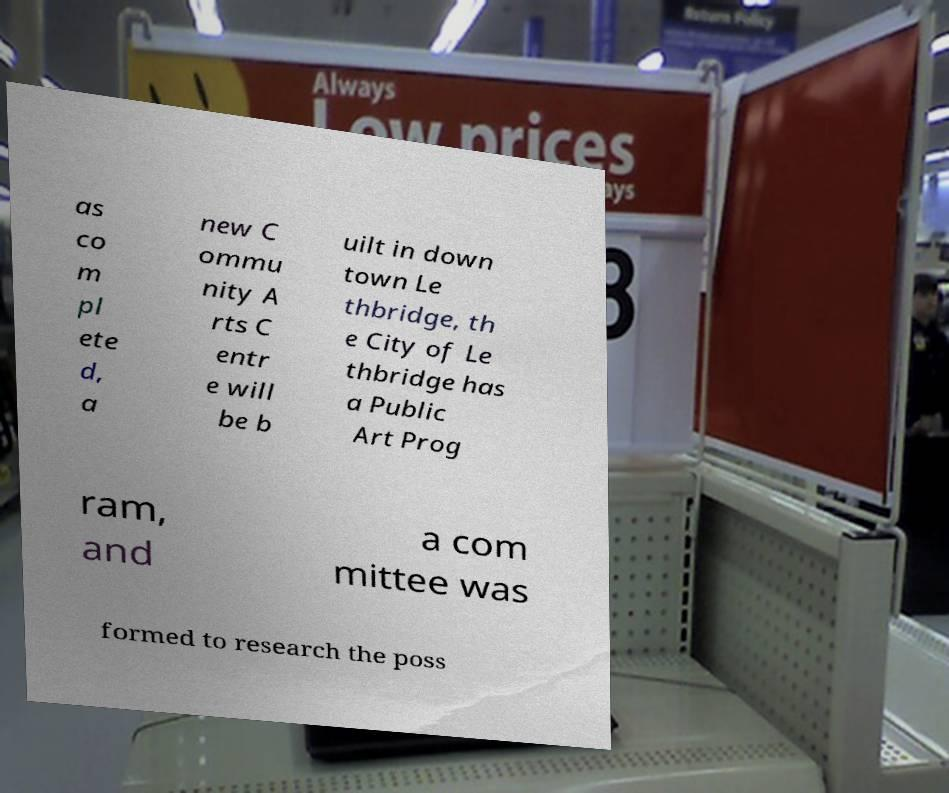Can you accurately transcribe the text from the provided image for me? as co m pl ete d, a new C ommu nity A rts C entr e will be b uilt in down town Le thbridge, th e City of Le thbridge has a Public Art Prog ram, and a com mittee was formed to research the poss 